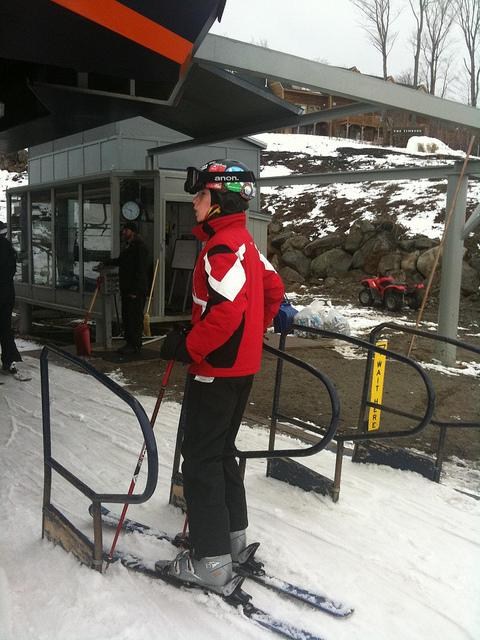What is the person in red most likely awaiting a turn for? Please explain your reasoning. ski lift. With the setting the man is in and the garb and equipment he is wearing, it's easy to understand what he is waiting for. 